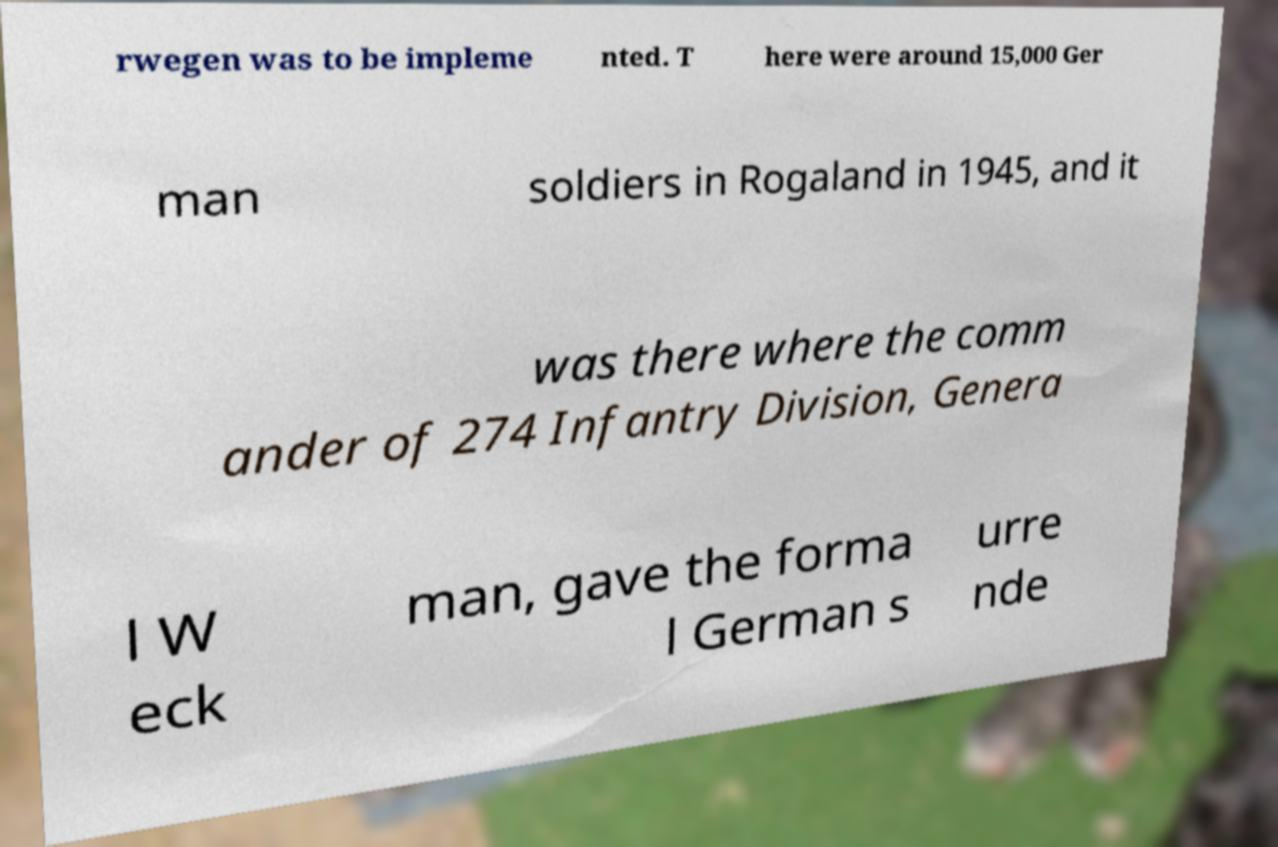Please identify and transcribe the text found in this image. rwegen was to be impleme nted. T here were around 15,000 Ger man soldiers in Rogaland in 1945, and it was there where the comm ander of 274 Infantry Division, Genera l W eck man, gave the forma l German s urre nde 